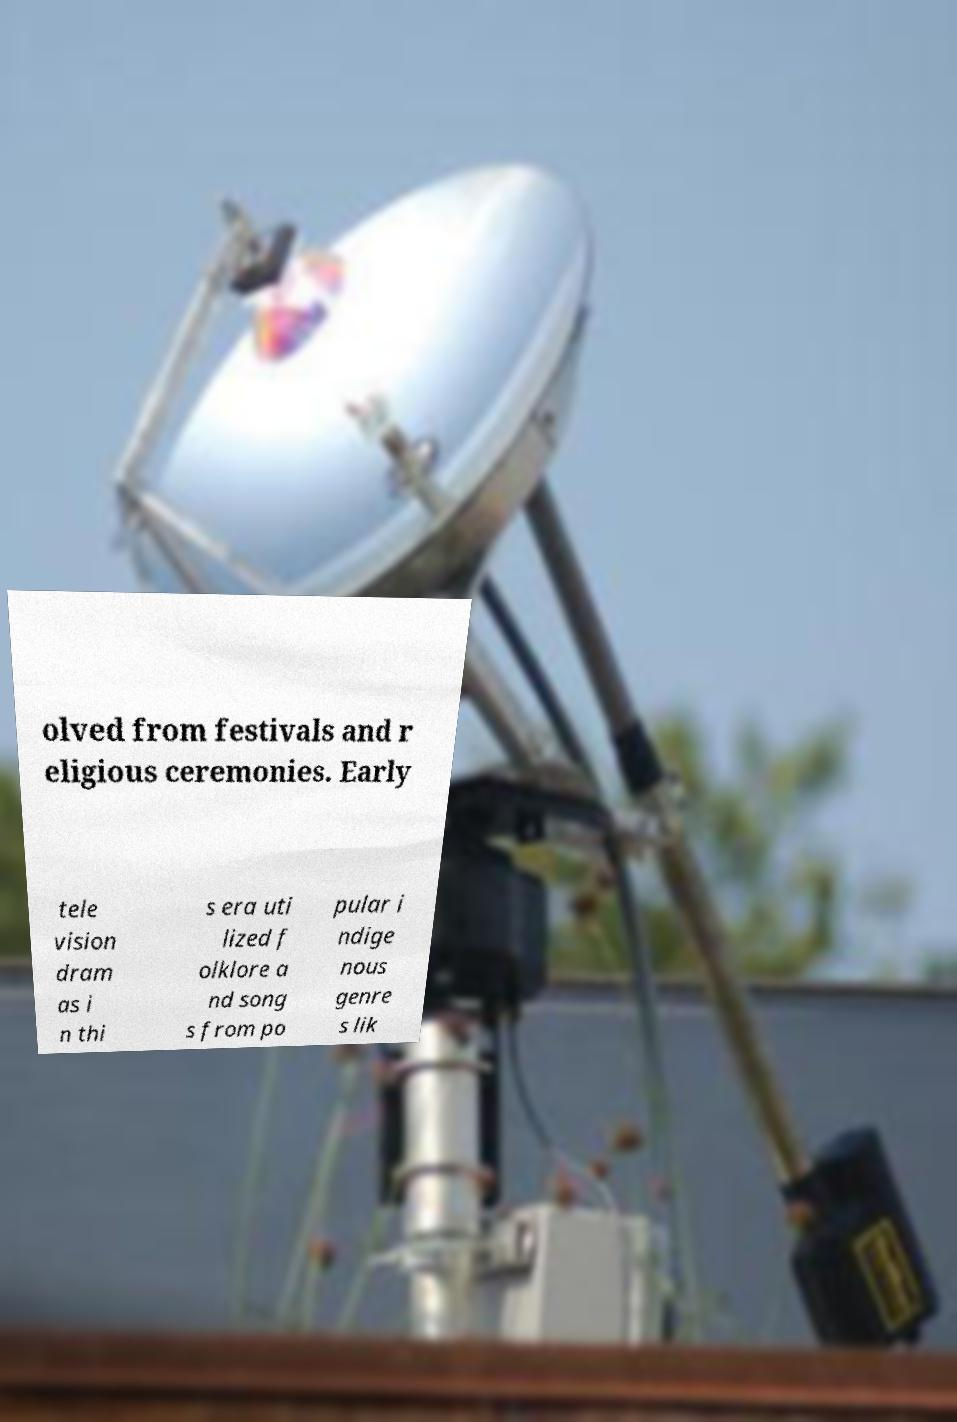Could you extract and type out the text from this image? olved from festivals and r eligious ceremonies. Early tele vision dram as i n thi s era uti lized f olklore a nd song s from po pular i ndige nous genre s lik 